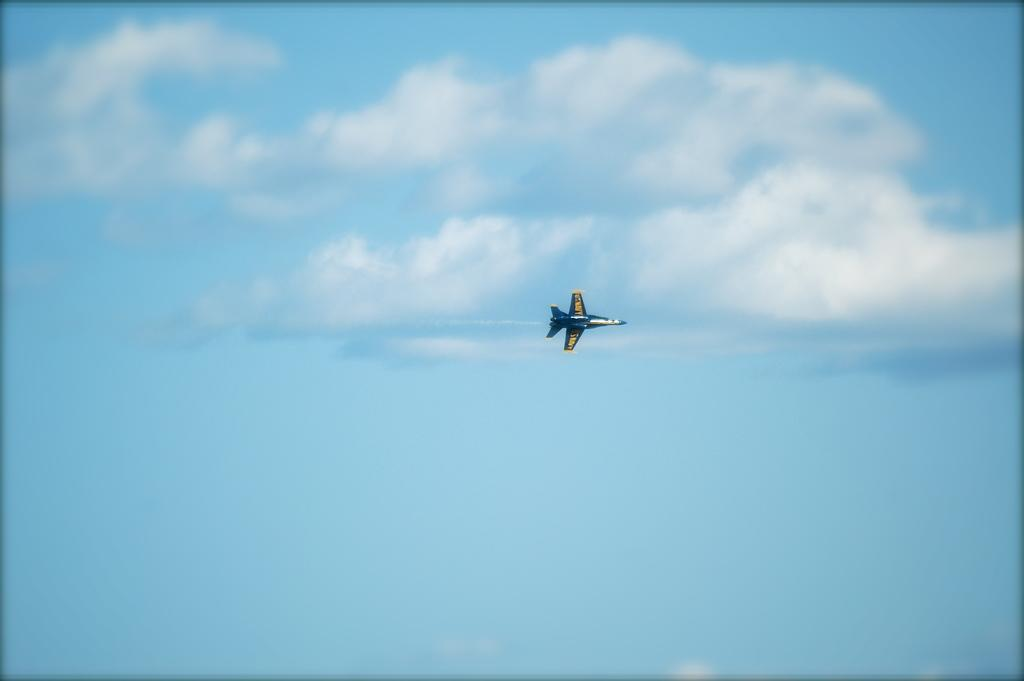What is the main subject of the image? The main subject of the image is an airplane. What is the airplane doing in the image? The airplane is flying in the sky. How many cubs can be seen playing with a thumb in the image? There are no cubs or thumbs present in the image; it features an airplane flying in the sky. What type of creature is shown interacting with the arm on the airplane in the image? There is no creature shown interacting with an arm on the airplane in the image; only the airplane is present. 